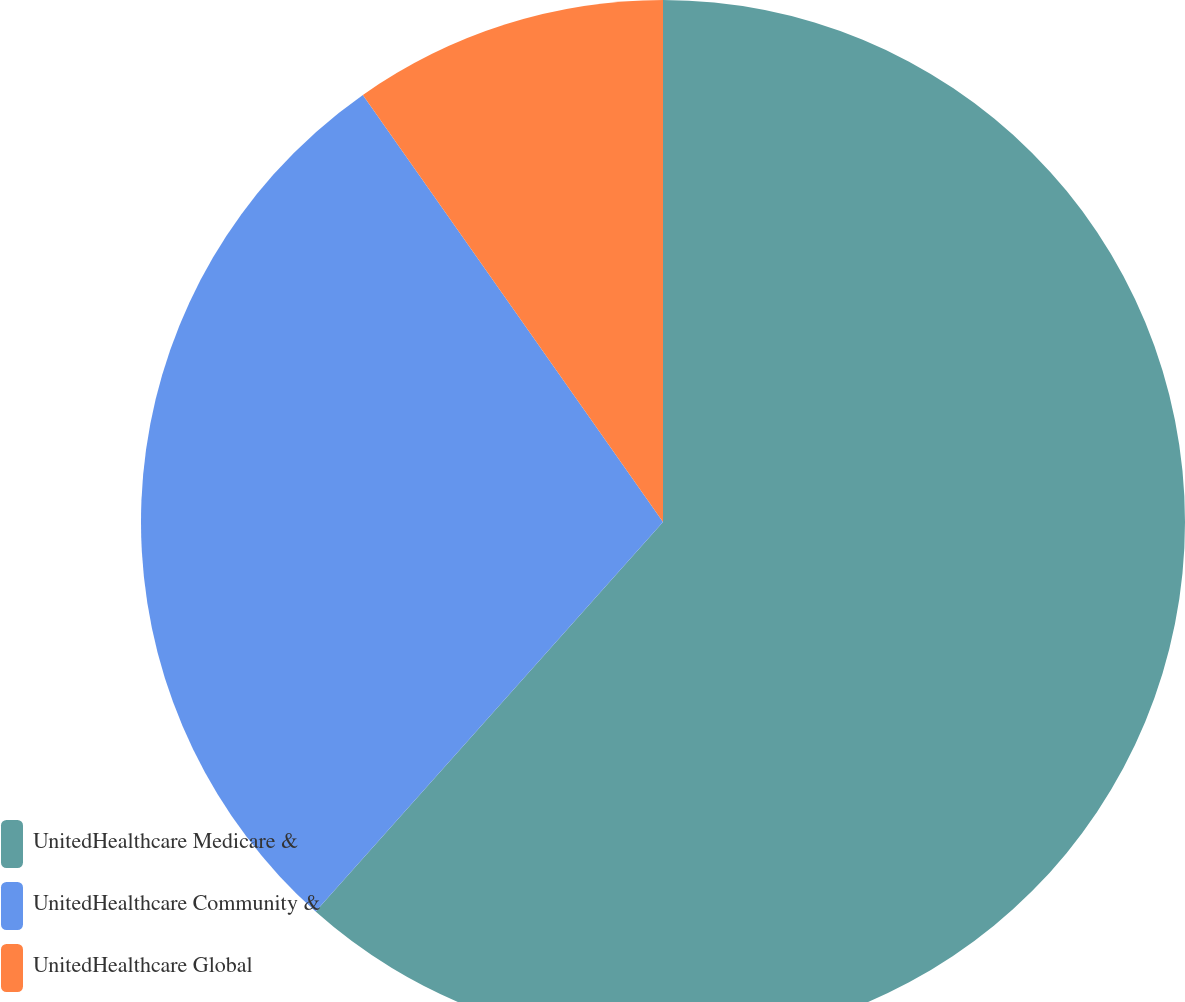Convert chart. <chart><loc_0><loc_0><loc_500><loc_500><pie_chart><fcel>UnitedHealthcare Medicare &<fcel>UnitedHealthcare Community &<fcel>UnitedHealthcare Global<nl><fcel>61.59%<fcel>28.66%<fcel>9.75%<nl></chart> 